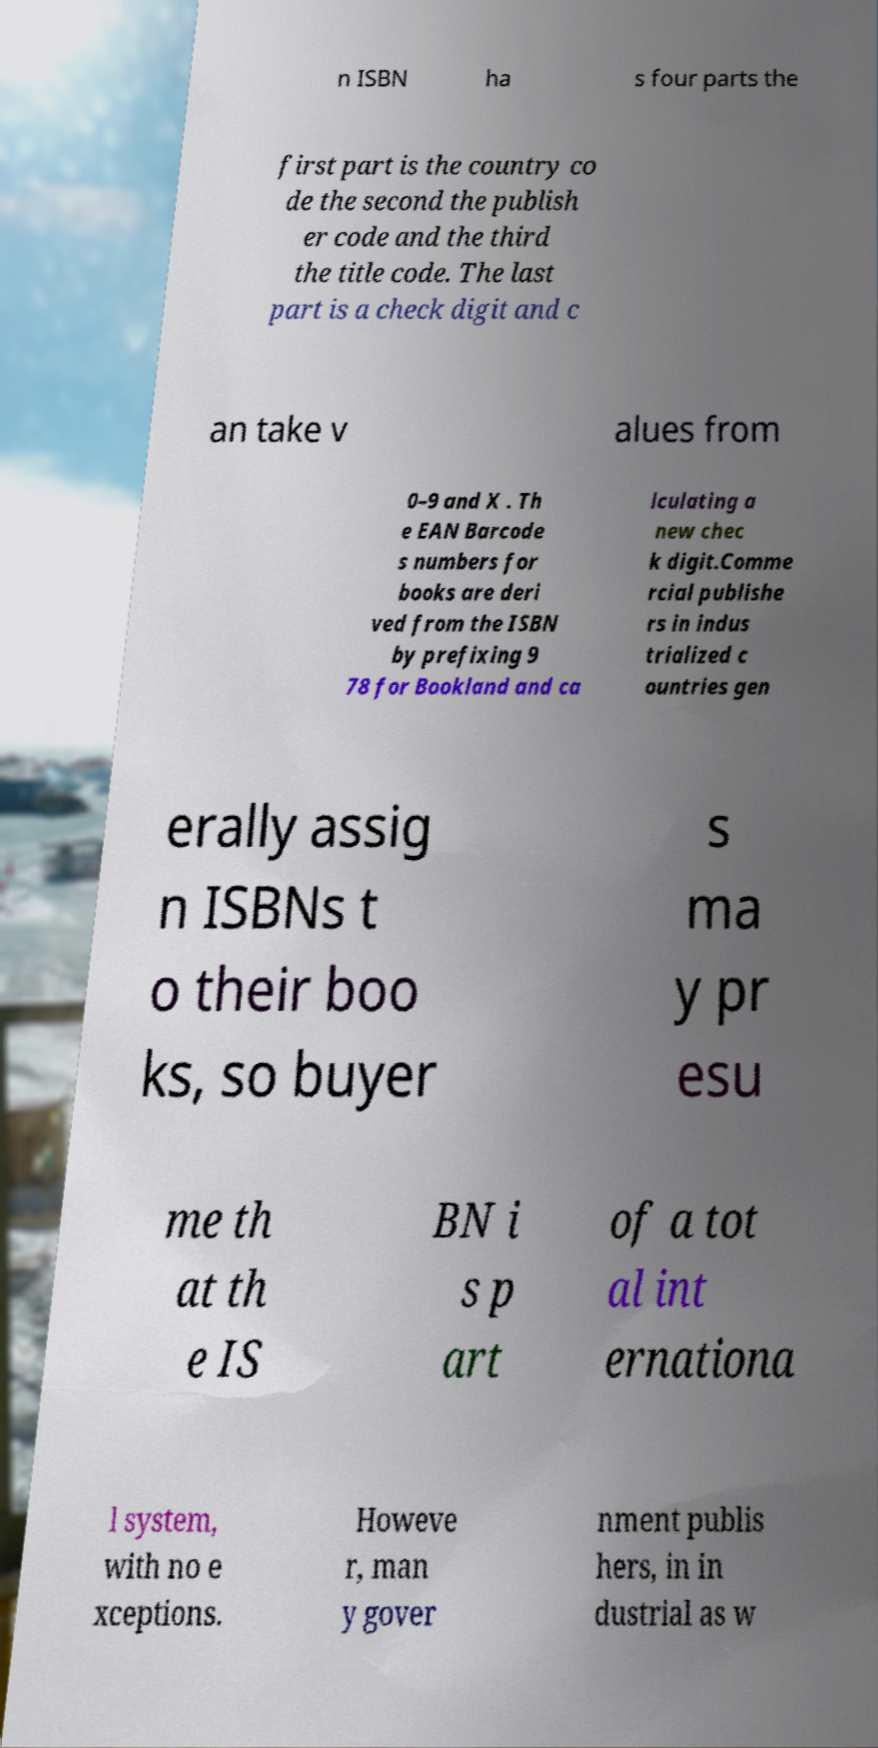For documentation purposes, I need the text within this image transcribed. Could you provide that? n ISBN ha s four parts the first part is the country co de the second the publish er code and the third the title code. The last part is a check digit and c an take v alues from 0–9 and X . Th e EAN Barcode s numbers for books are deri ved from the ISBN by prefixing 9 78 for Bookland and ca lculating a new chec k digit.Comme rcial publishe rs in indus trialized c ountries gen erally assig n ISBNs t o their boo ks, so buyer s ma y pr esu me th at th e IS BN i s p art of a tot al int ernationa l system, with no e xceptions. Howeve r, man y gover nment publis hers, in in dustrial as w 